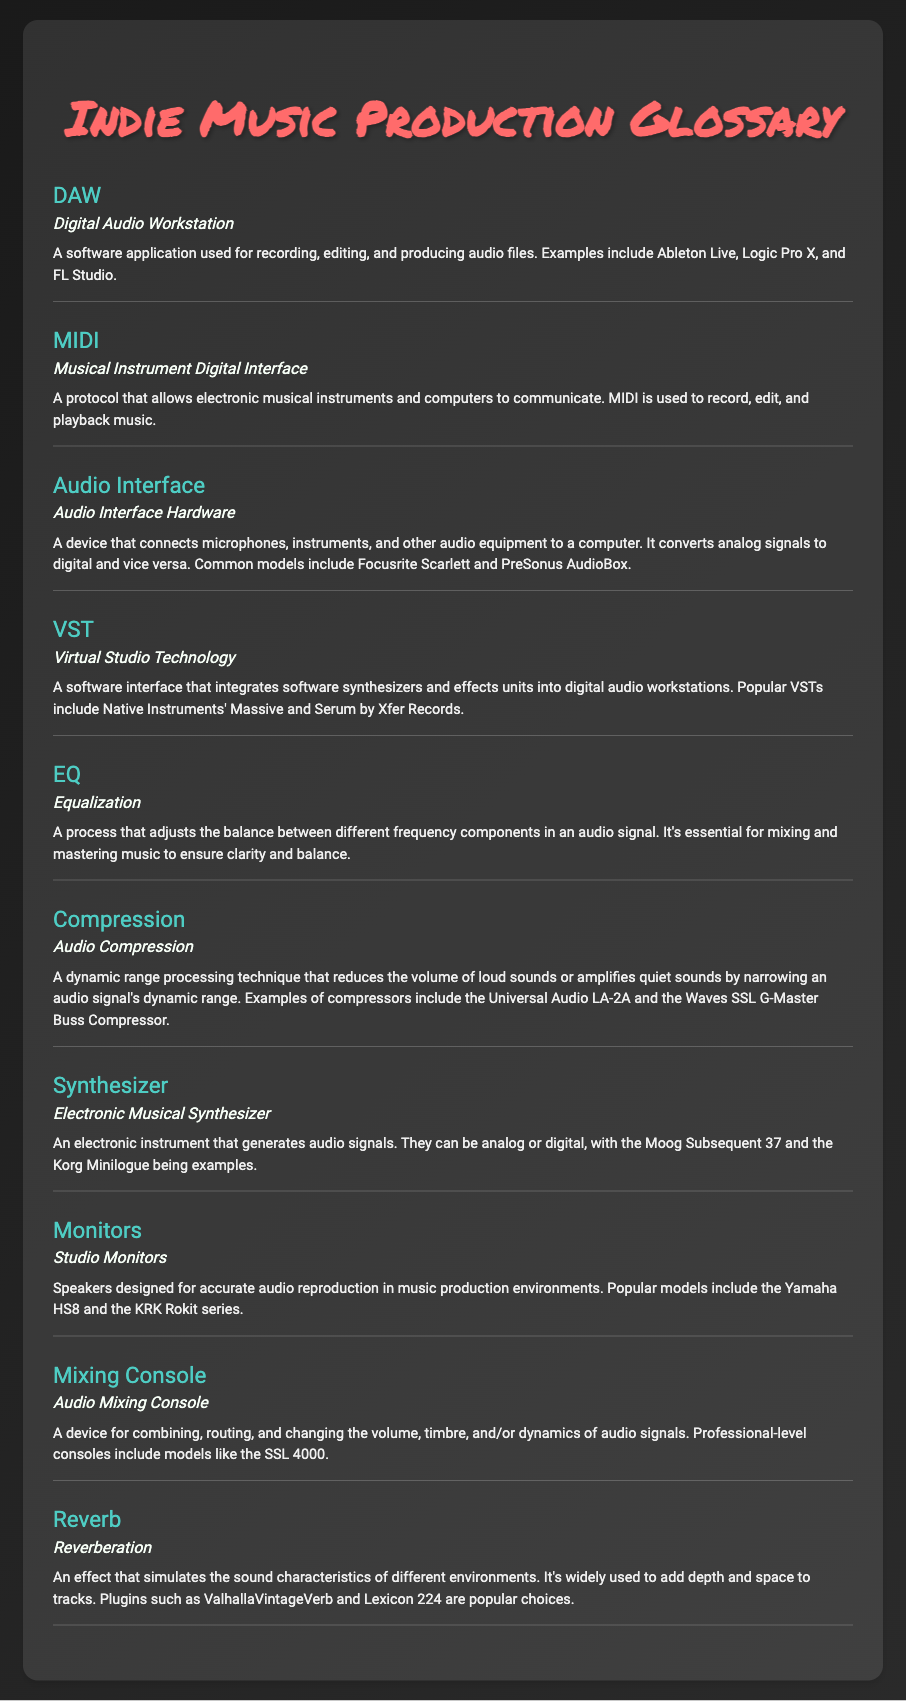What does DAW stand for? The term DAW stands for Digital Audio Workstation.
Answer: Digital Audio Workstation What type of device is an Audio Interface? An Audio Interface is a hardware device that connects microphones, instruments, and other audio equipment to a computer.
Answer: Audio Interface Hardware What is the purpose of EQ? EQ, or Equalization, adjusts the balance between different frequency components in an audio signal.
Answer: Equalization Which VSTs are mentioned in the document? The document mentions Native Instruments' Massive and Serum by Xfer Records as popular VSTs.
Answer: Massive and Serum What is the effect of Reverb? Reverb simulates the sound characteristics of different environments and adds depth and space to tracks.
Answer: Reverberation How does Compression function in audio? Compression reduces the volume of loud sounds or amplifies quiet sounds by narrowing an audio signal's dynamic range.
Answer: Audio Compression What is a popular model of Studio Monitors? A popular model of Studio Monitors is the Yamaha HS8.
Answer: Yamaha HS8 How many glossary items are listed in the document? The document contains a total of ten glossary items.
Answer: ten 